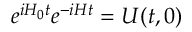Convert formula to latex. <formula><loc_0><loc_0><loc_500><loc_500>e ^ { i H _ { 0 } t } e ^ { - i H t } = U ( t , 0 )</formula> 